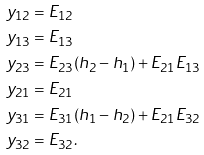Convert formula to latex. <formula><loc_0><loc_0><loc_500><loc_500>y _ { 1 2 } & = E _ { 1 2 } \\ y _ { 1 3 } & = E _ { 1 3 } \\ y _ { 2 3 } & = E _ { 2 3 } ( h _ { 2 } - h _ { 1 } ) + E _ { 2 1 } E _ { 1 3 } \\ y _ { 2 1 } & = E _ { 2 1 } \\ y _ { 3 1 } & = E _ { 3 1 } ( h _ { 1 } - h _ { 2 } ) + E _ { 2 1 } E _ { 3 2 } \\ y _ { 3 2 } & = E _ { 3 2 } .</formula> 